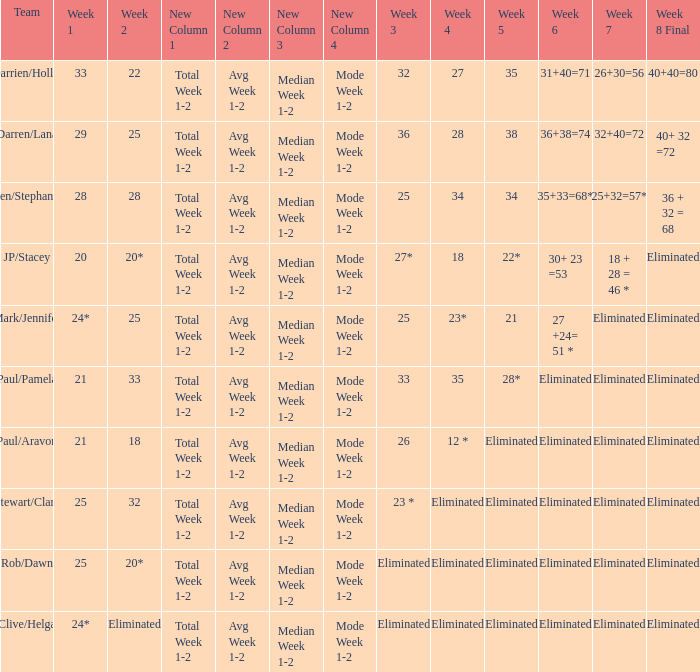Name the week 3 for team of mark/jennifer 25.0. 